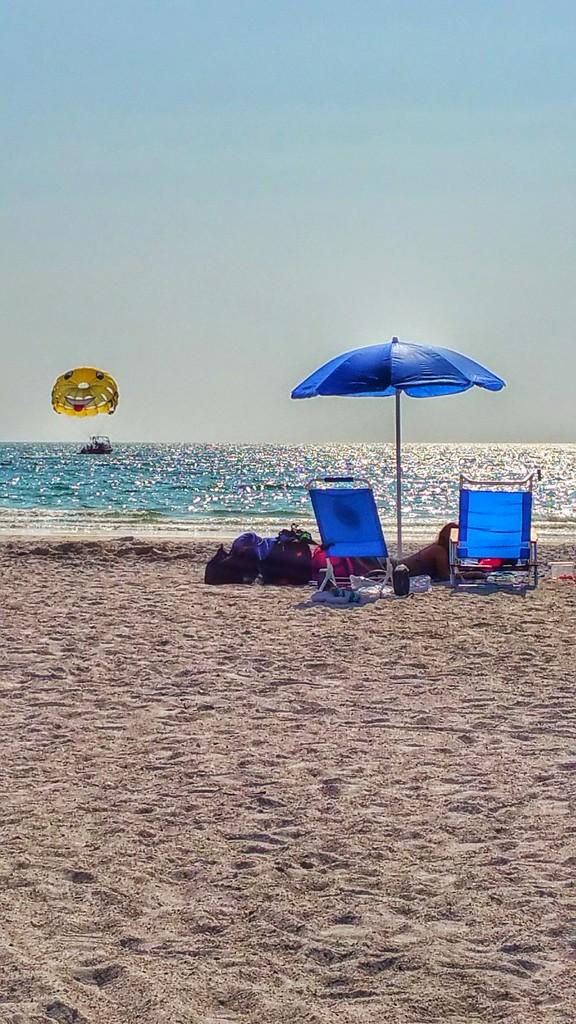What objects are located in the center of the image? There are chairs, backpacks, a bottle, sand, a blanket, and an outdoor umbrella in the center of the image. What is the person in the center of the image doing? There is a person lying in the center of the image. What can be seen in the background of the image? Sky, water, and a parachute are visible in the background of the image. How many balloons are tied to the chairs in the image? There are no balloons present in the image; only chairs, backpacks, a bottle, sand, a blanket, and an outdoor umbrella are visible in the center of the image. What type of alley can be seen in the background of the image? There is no alley present in the image; the background features sky, water, and a parachute. 